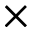Convert formula to latex. <formula><loc_0><loc_0><loc_500><loc_500>\times</formula> 